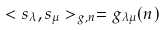Convert formula to latex. <formula><loc_0><loc_0><loc_500><loc_500>< s _ { \lambda } , s _ { \mu } > _ { g , n } = g _ { \lambda \mu } ( n )</formula> 